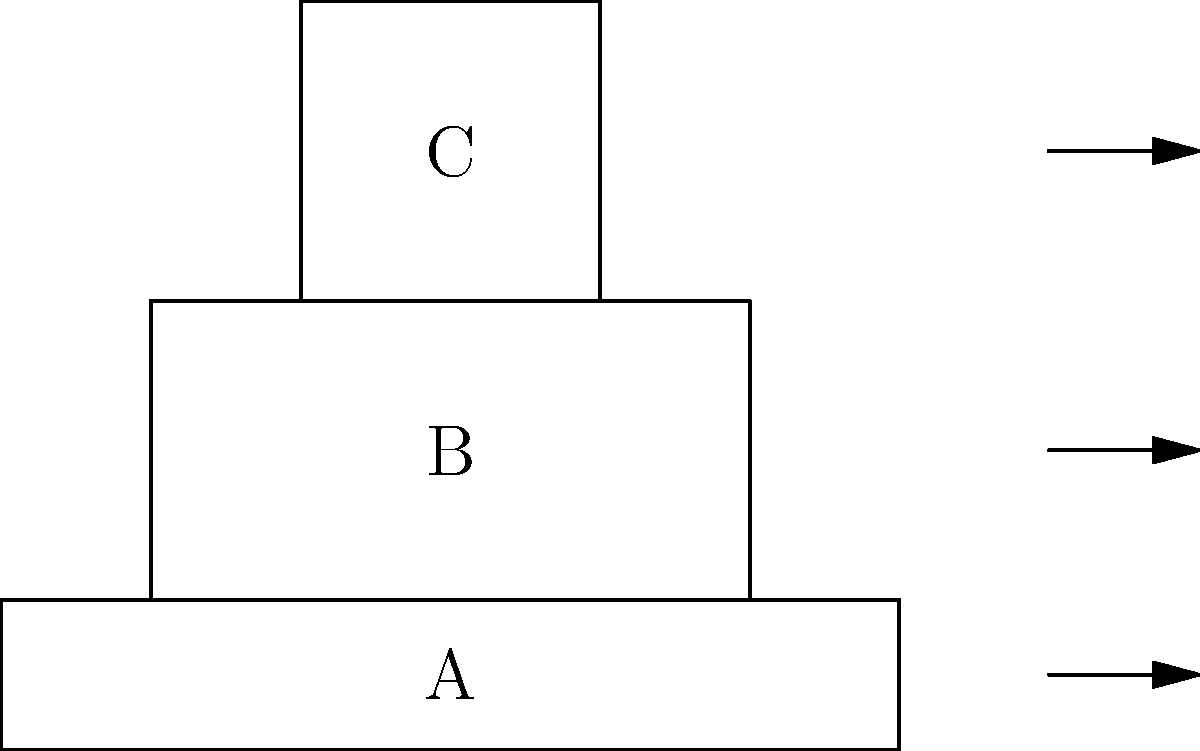The diagram shows the disassembled parts of a field shovel. Which sequence correctly represents the order of assembly from bottom to top? To mentally reconstruct this field shovel, we need to analyze the diagram and consider the logical assembly order:

1. Part A is clearly the base or blade of the shovel. It's the widest part and would form the foundation of the tool.

2. Part B appears to be the handle connector. It has two vertical pieces that would attach to the base and support the upper part.

3. Part C is the top part of the handle. It's narrower than part B and would logically fit on top to complete the shovel.

The correct assembly order from bottom to top would be:

1. A (base/blade)
2. B (handle connector)
3. C (handle top)

This sequence ensures a stable and functional construction of the field shovel, reminiscent of standard military-issue entrenching tools.
Answer: A-B-C 